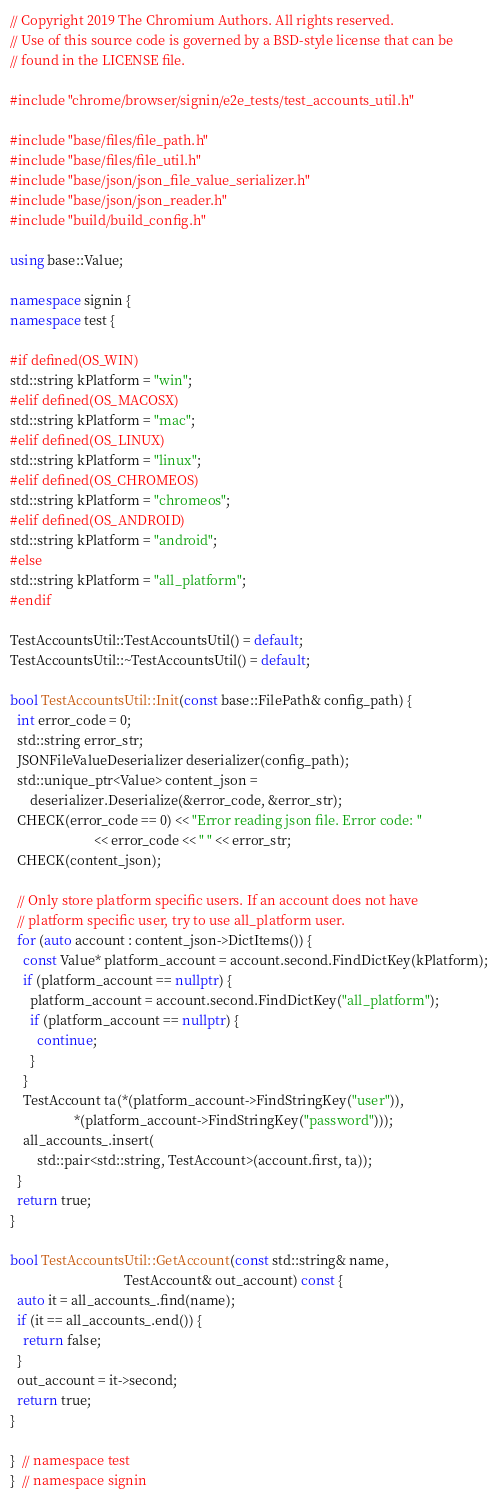Convert code to text. <code><loc_0><loc_0><loc_500><loc_500><_C++_>// Copyright 2019 The Chromium Authors. All rights reserved.
// Use of this source code is governed by a BSD-style license that can be
// found in the LICENSE file.

#include "chrome/browser/signin/e2e_tests/test_accounts_util.h"

#include "base/files/file_path.h"
#include "base/files/file_util.h"
#include "base/json/json_file_value_serializer.h"
#include "base/json/json_reader.h"
#include "build/build_config.h"

using base::Value;

namespace signin {
namespace test {

#if defined(OS_WIN)
std::string kPlatform = "win";
#elif defined(OS_MACOSX)
std::string kPlatform = "mac";
#elif defined(OS_LINUX)
std::string kPlatform = "linux";
#elif defined(OS_CHROMEOS)
std::string kPlatform = "chromeos";
#elif defined(OS_ANDROID)
std::string kPlatform = "android";
#else
std::string kPlatform = "all_platform";
#endif

TestAccountsUtil::TestAccountsUtil() = default;
TestAccountsUtil::~TestAccountsUtil() = default;

bool TestAccountsUtil::Init(const base::FilePath& config_path) {
  int error_code = 0;
  std::string error_str;
  JSONFileValueDeserializer deserializer(config_path);
  std::unique_ptr<Value> content_json =
      deserializer.Deserialize(&error_code, &error_str);
  CHECK(error_code == 0) << "Error reading json file. Error code: "
                         << error_code << " " << error_str;
  CHECK(content_json);

  // Only store platform specific users. If an account does not have
  // platform specific user, try to use all_platform user.
  for (auto account : content_json->DictItems()) {
    const Value* platform_account = account.second.FindDictKey(kPlatform);
    if (platform_account == nullptr) {
      platform_account = account.second.FindDictKey("all_platform");
      if (platform_account == nullptr) {
        continue;
      }
    }
    TestAccount ta(*(platform_account->FindStringKey("user")),
                   *(platform_account->FindStringKey("password")));
    all_accounts_.insert(
        std::pair<std::string, TestAccount>(account.first, ta));
  }
  return true;
}

bool TestAccountsUtil::GetAccount(const std::string& name,
                                  TestAccount& out_account) const {
  auto it = all_accounts_.find(name);
  if (it == all_accounts_.end()) {
    return false;
  }
  out_account = it->second;
  return true;
}

}  // namespace test
}  // namespace signin
</code> 